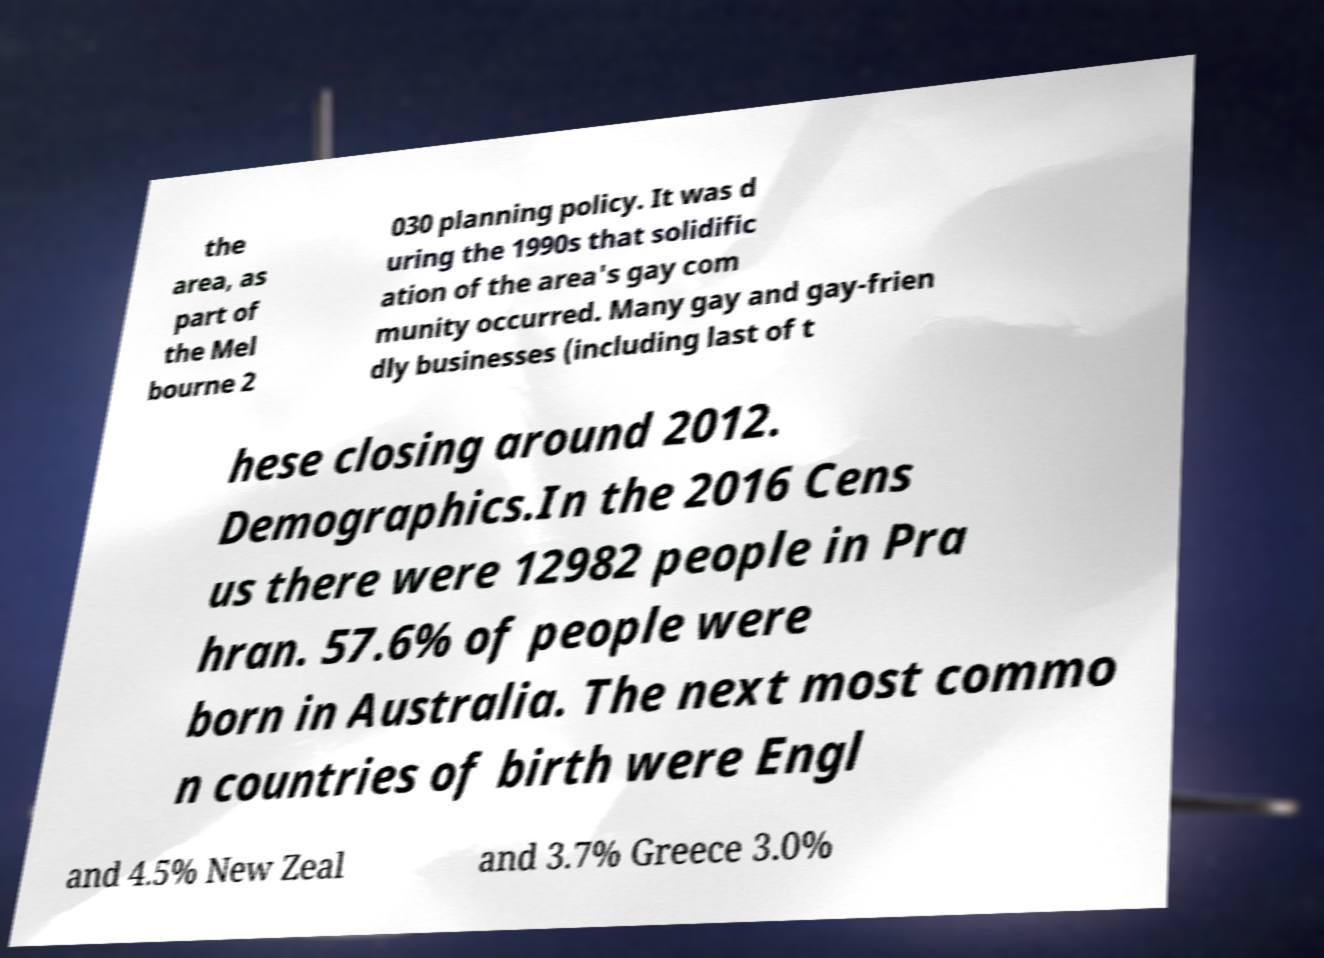Could you extract and type out the text from this image? the area, as part of the Mel bourne 2 030 planning policy. It was d uring the 1990s that solidific ation of the area's gay com munity occurred. Many gay and gay-frien dly businesses (including last of t hese closing around 2012. Demographics.In the 2016 Cens us there were 12982 people in Pra hran. 57.6% of people were born in Australia. The next most commo n countries of birth were Engl and 4.5% New Zeal and 3.7% Greece 3.0% 